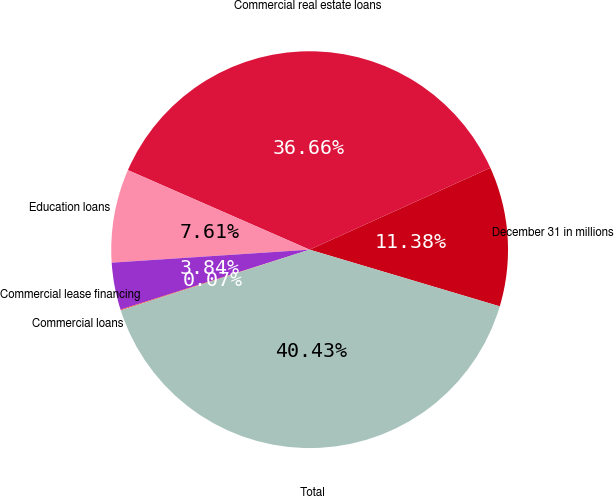Convert chart. <chart><loc_0><loc_0><loc_500><loc_500><pie_chart><fcel>December 31 in millions<fcel>Commercial real estate loans<fcel>Education loans<fcel>Commercial lease financing<fcel>Commercial loans<fcel>Total<nl><fcel>11.38%<fcel>36.66%<fcel>7.61%<fcel>3.84%<fcel>0.07%<fcel>40.43%<nl></chart> 